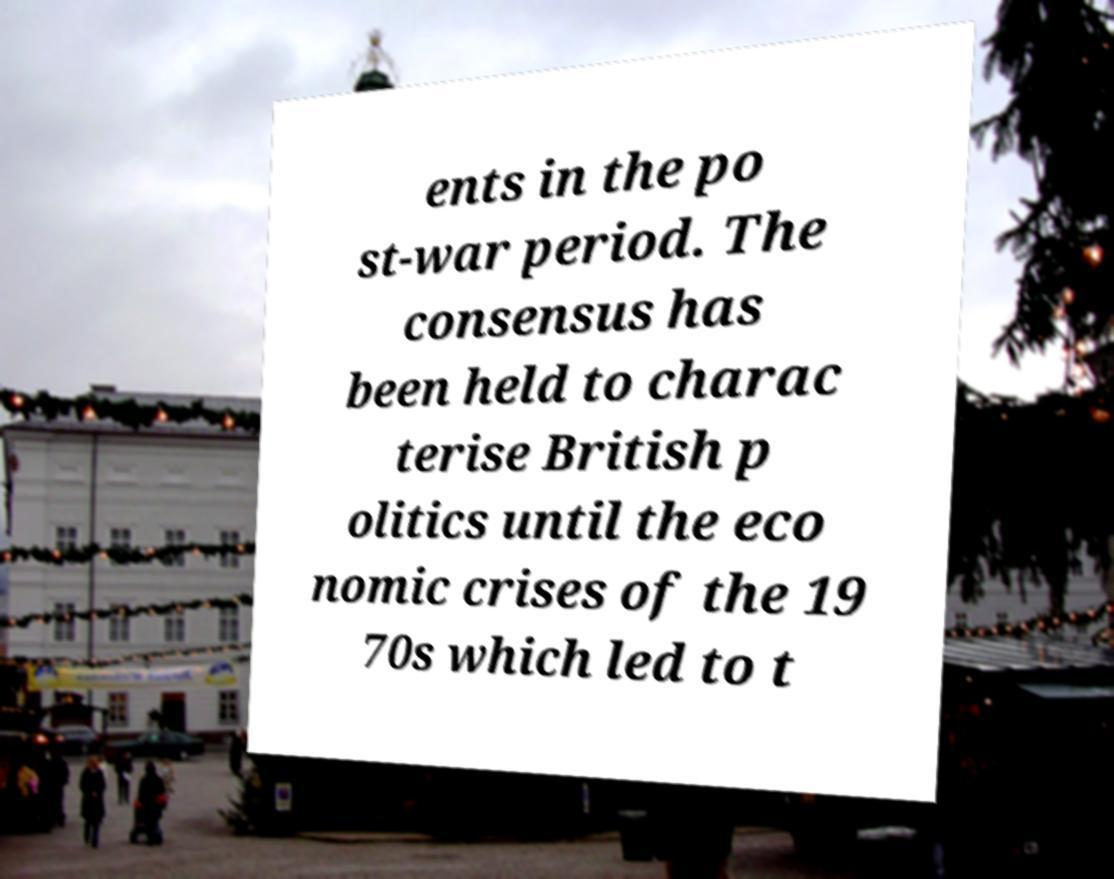Could you assist in decoding the text presented in this image and type it out clearly? ents in the po st-war period. The consensus has been held to charac terise British p olitics until the eco nomic crises of the 19 70s which led to t 